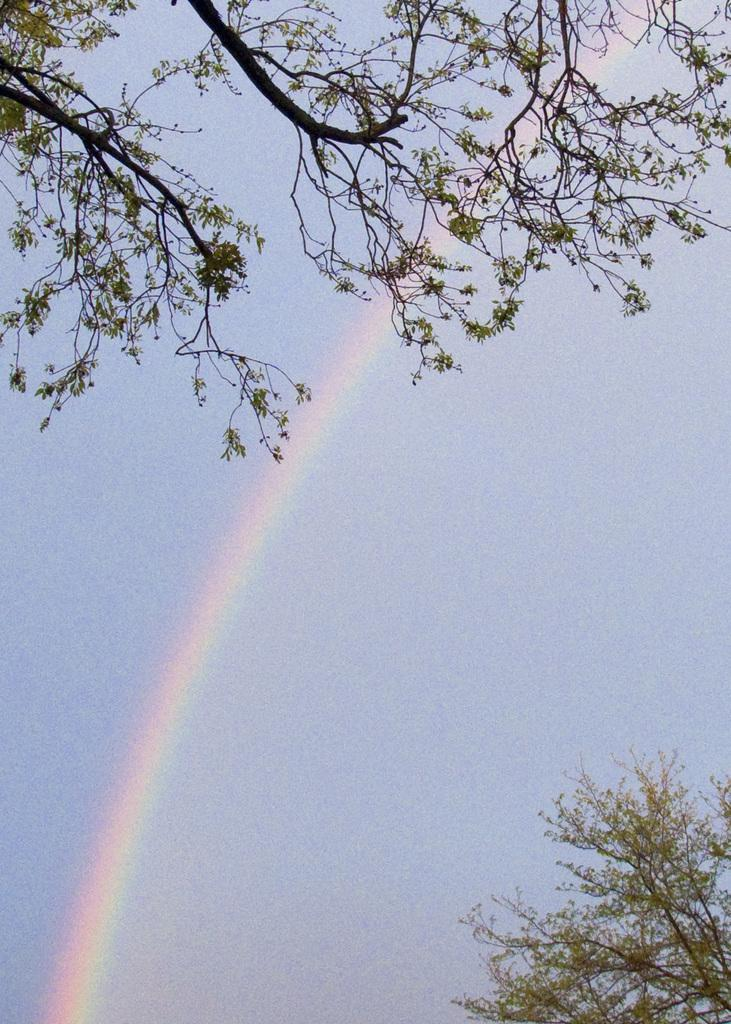What type of vegetation can be seen at the top of the image? There are branches at the top of the image. What type of vegetation can be seen at the bottom of the image? There are branches at the bottom of the image. What can be seen in the background of the image? Sky is visible in the background of the image. What natural phenomenon is present in the sky? A rainbow is present in the sky. What type of hill can be seen in the image? There is no hill present in the image; it features branches and a sky with a rainbow. 